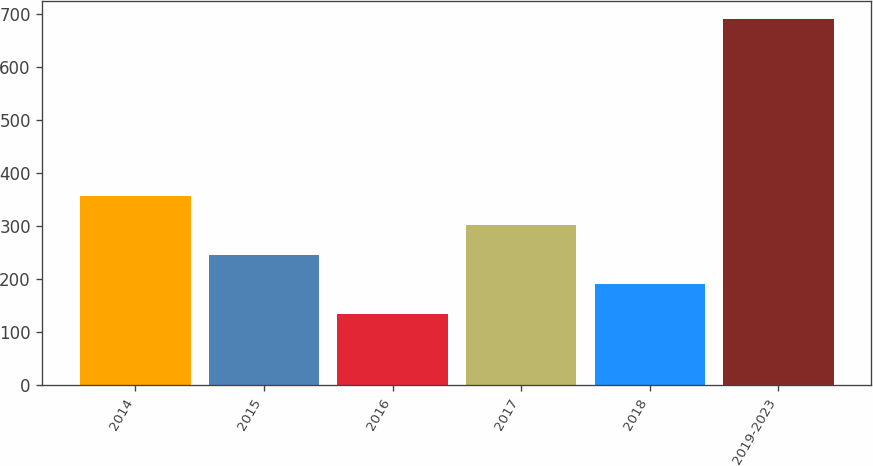Convert chart. <chart><loc_0><loc_0><loc_500><loc_500><bar_chart><fcel>2014<fcel>2015<fcel>2016<fcel>2017<fcel>2018<fcel>2019-2023<nl><fcel>357.4<fcel>246.2<fcel>135<fcel>301.8<fcel>190.6<fcel>691<nl></chart> 